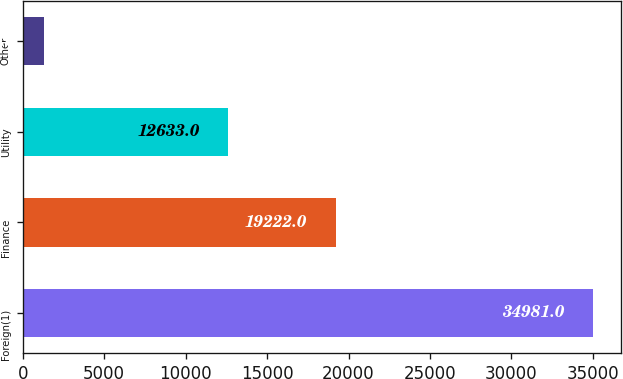Convert chart. <chart><loc_0><loc_0><loc_500><loc_500><bar_chart><fcel>Foreign(1)<fcel>Finance<fcel>Utility<fcel>Other<nl><fcel>34981<fcel>19222<fcel>12633<fcel>1323<nl></chart> 